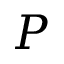<formula> <loc_0><loc_0><loc_500><loc_500>P</formula> 